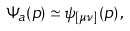Convert formula to latex. <formula><loc_0><loc_0><loc_500><loc_500>\Psi _ { a } ( p ) \simeq \psi _ { [ \mu \nu ] } ( p ) \, ,</formula> 